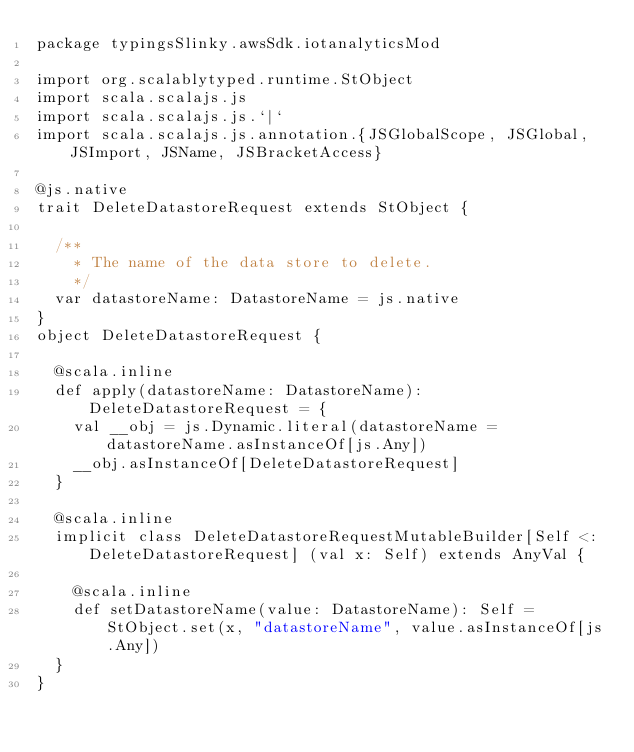Convert code to text. <code><loc_0><loc_0><loc_500><loc_500><_Scala_>package typingsSlinky.awsSdk.iotanalyticsMod

import org.scalablytyped.runtime.StObject
import scala.scalajs.js
import scala.scalajs.js.`|`
import scala.scalajs.js.annotation.{JSGlobalScope, JSGlobal, JSImport, JSName, JSBracketAccess}

@js.native
trait DeleteDatastoreRequest extends StObject {
  
  /**
    * The name of the data store to delete.
    */
  var datastoreName: DatastoreName = js.native
}
object DeleteDatastoreRequest {
  
  @scala.inline
  def apply(datastoreName: DatastoreName): DeleteDatastoreRequest = {
    val __obj = js.Dynamic.literal(datastoreName = datastoreName.asInstanceOf[js.Any])
    __obj.asInstanceOf[DeleteDatastoreRequest]
  }
  
  @scala.inline
  implicit class DeleteDatastoreRequestMutableBuilder[Self <: DeleteDatastoreRequest] (val x: Self) extends AnyVal {
    
    @scala.inline
    def setDatastoreName(value: DatastoreName): Self = StObject.set(x, "datastoreName", value.asInstanceOf[js.Any])
  }
}
</code> 